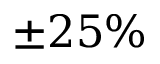Convert formula to latex. <formula><loc_0><loc_0><loc_500><loc_500>\pm 2 5 \%</formula> 